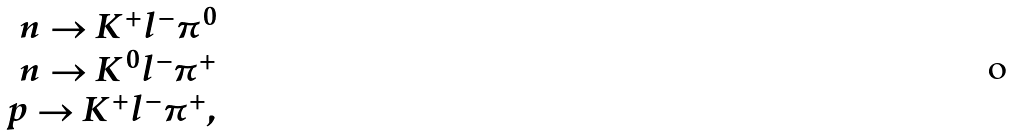Convert formula to latex. <formula><loc_0><loc_0><loc_500><loc_500>\begin{array} { r } n \to K ^ { + } l ^ { - } \pi ^ { 0 } \\ n \to K ^ { 0 } l ^ { - } \pi ^ { + } \\ p \to K ^ { + } l ^ { - } \pi ^ { + } , \end{array}</formula> 